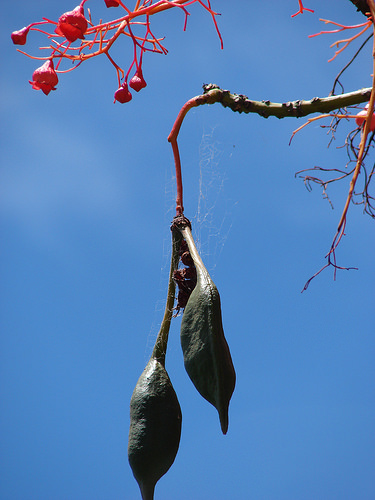<image>
Is there a tree next to the sky? No. The tree is not positioned next to the sky. They are located in different areas of the scene. 